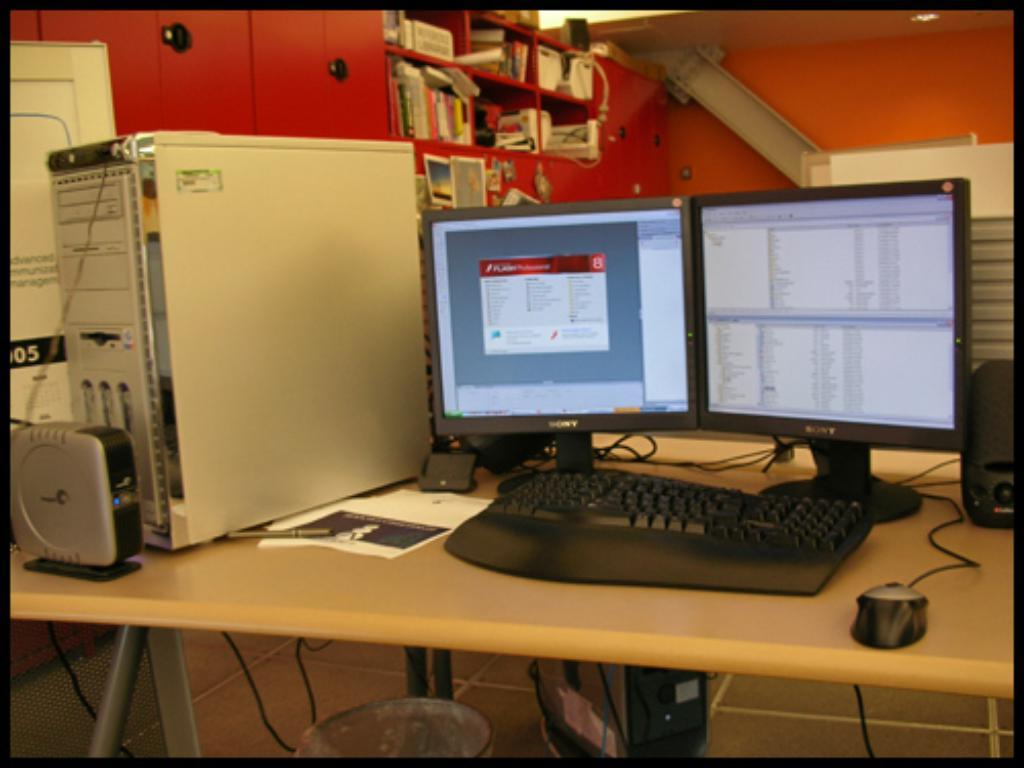What electronic device is on the table in the image? There is a computer on the table in the image. What is used to input commands into the computer? There is a keyboard on the table, which is used to input commands into the computer. What is the main processing unit of the computer? There is a CPU on the table, which is the main processing unit of the computer. What is used to navigate the computer's interface? There is a mouse on the table, which is used to navigate the computer's interface. What type of stationery items are on the table? There are papers and a pen on the table. What other objects can be seen on the table? There are other objects on the table, but their specific details are not mentioned in the provided facts. What can be seen in the background of the image? There is a wall visible in the image. How many feet are visible in the image? There are no feet visible in the image. What type of flock is flying in the background of the image? There is no flock visible in the image; only a wall is present in the background. 